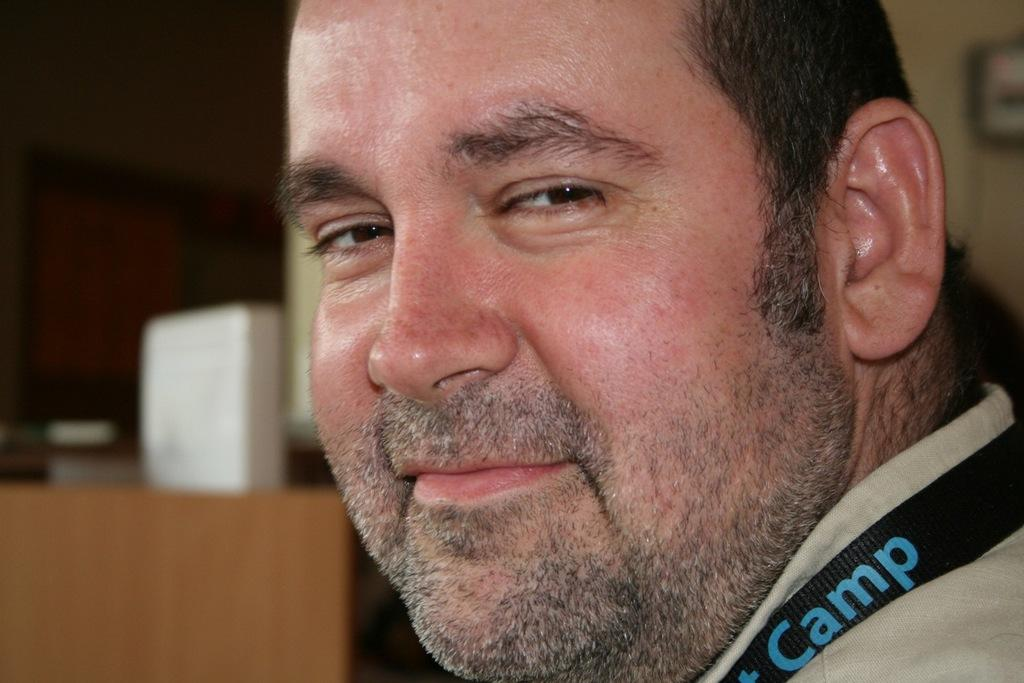Who is present in the image? There is a man in the image. What is the man's facial expression? The man is smiling. What can be seen in the background of the image? There is a painting on the wall in the background of the image. What type of breakfast is the man eating in the image? There is no breakfast present in the image; it only features a man smiling with a painting on the wall in the background. 